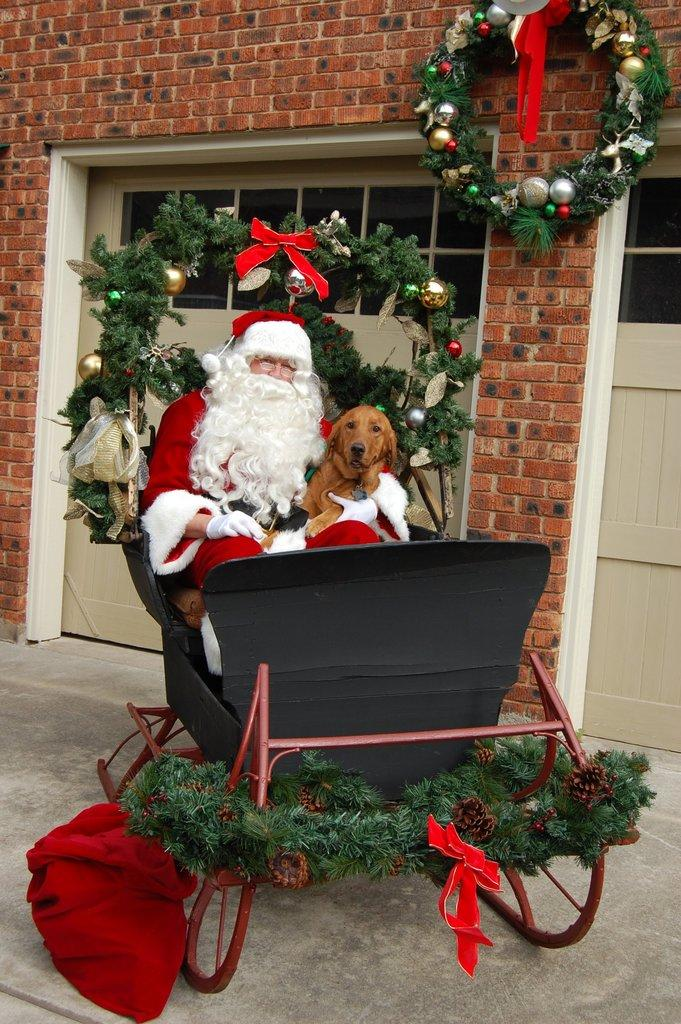Who is the main character in the image? There is a Santa Claus in the image. What other living creature is present in the image? There is a dog in the image. Where are Santa Claus and the dog located? Both Santa Claus and the dog are in a decorated trolley. What can be seen in the background of the image? There is a door visible in the background of the image. What type of bridge can be seen in the image? There is no bridge present in the image. How does the trolley move in the image? The image is static, so the motion of the trolley cannot be determined. 